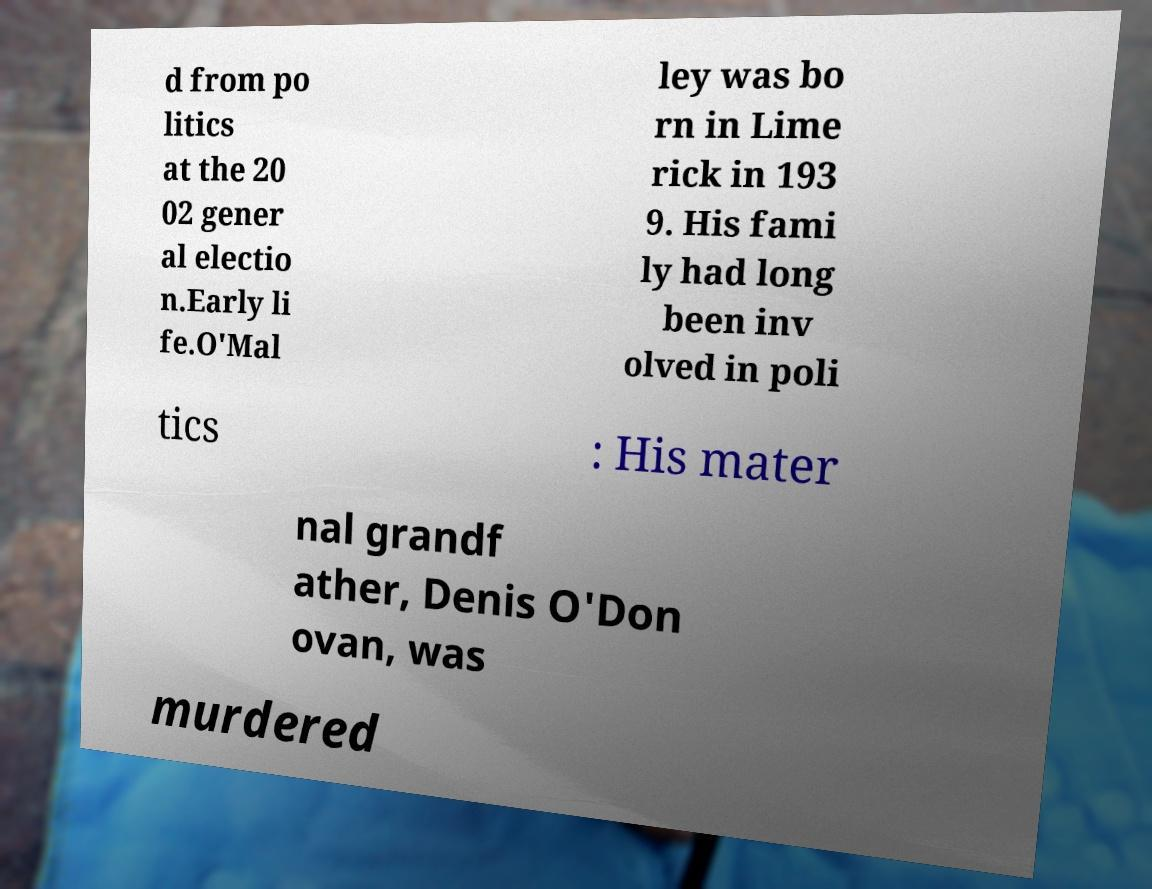There's text embedded in this image that I need extracted. Can you transcribe it verbatim? d from po litics at the 20 02 gener al electio n.Early li fe.O'Mal ley was bo rn in Lime rick in 193 9. His fami ly had long been inv olved in poli tics : His mater nal grandf ather, Denis O'Don ovan, was murdered 